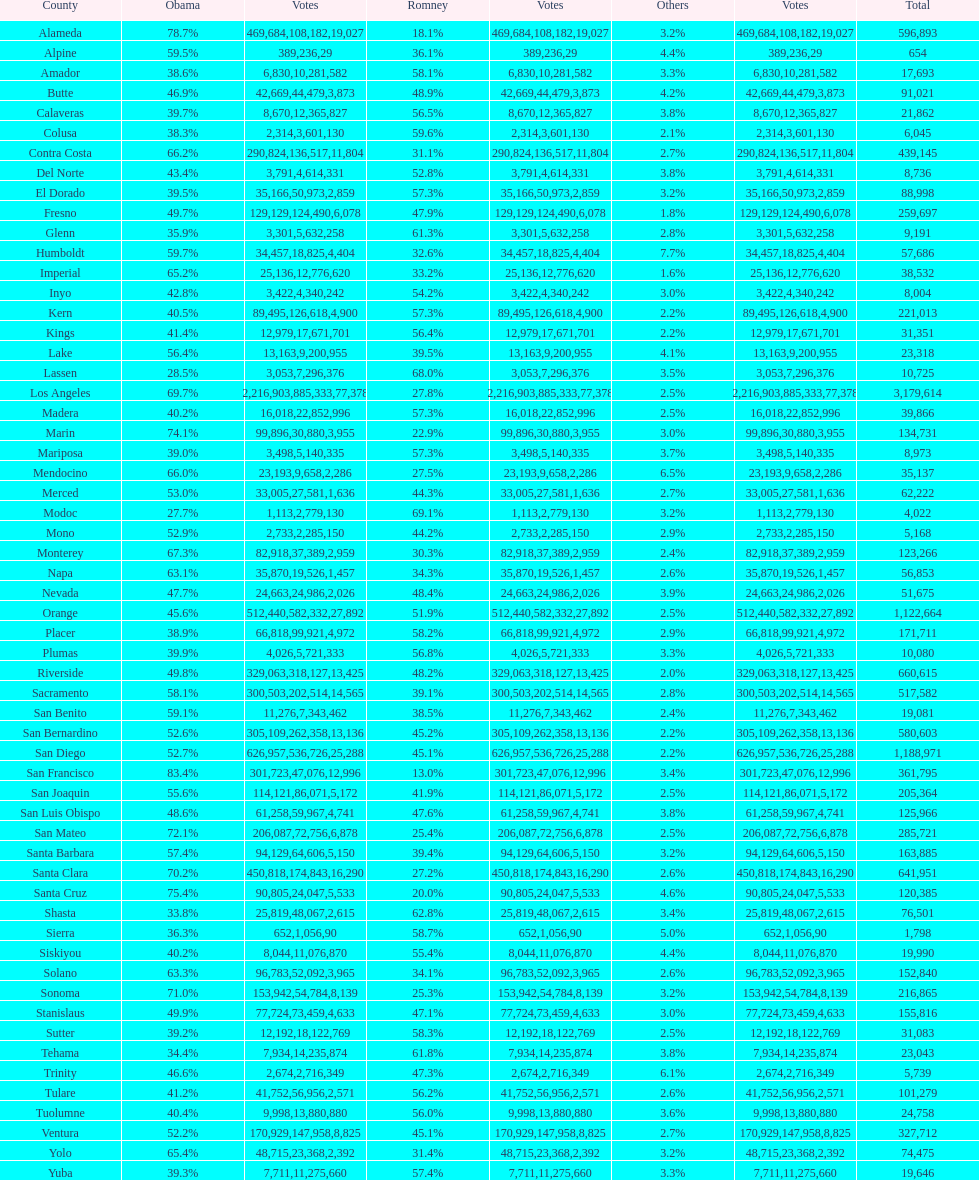Out of amador, humboldt, and lake counties, which one had the least percentage of votes for obama? Amador. 